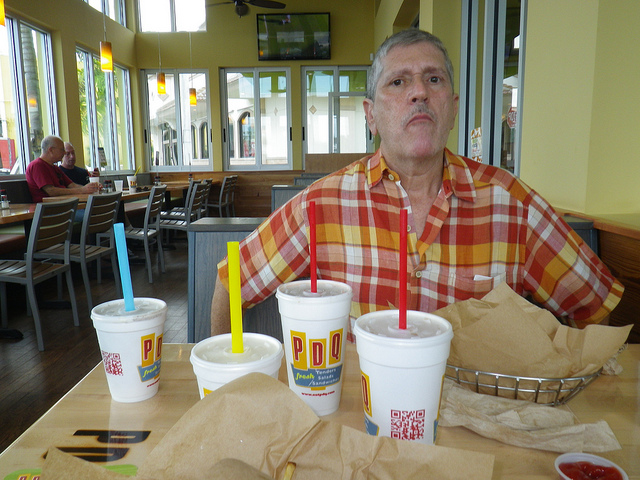Please transcribe the text information in this image. P D Q P PD fresh D 